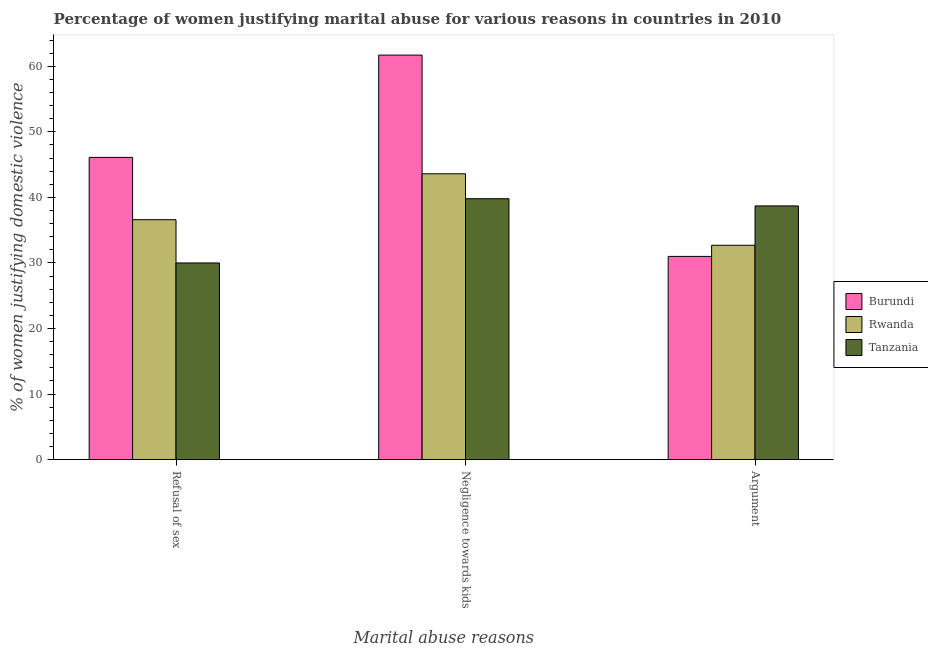How many groups of bars are there?
Make the answer very short. 3. How many bars are there on the 1st tick from the left?
Keep it short and to the point. 3. What is the label of the 1st group of bars from the left?
Keep it short and to the point. Refusal of sex. What is the percentage of women justifying domestic violence due to negligence towards kids in Tanzania?
Your response must be concise. 39.8. Across all countries, what is the maximum percentage of women justifying domestic violence due to arguments?
Make the answer very short. 38.7. Across all countries, what is the minimum percentage of women justifying domestic violence due to negligence towards kids?
Ensure brevity in your answer.  39.8. In which country was the percentage of women justifying domestic violence due to refusal of sex maximum?
Provide a succinct answer. Burundi. In which country was the percentage of women justifying domestic violence due to negligence towards kids minimum?
Make the answer very short. Tanzania. What is the total percentage of women justifying domestic violence due to negligence towards kids in the graph?
Give a very brief answer. 145.1. What is the difference between the percentage of women justifying domestic violence due to refusal of sex in Tanzania and the percentage of women justifying domestic violence due to negligence towards kids in Burundi?
Offer a terse response. -31.7. What is the average percentage of women justifying domestic violence due to negligence towards kids per country?
Make the answer very short. 48.37. What is the difference between the percentage of women justifying domestic violence due to arguments and percentage of women justifying domestic violence due to negligence towards kids in Rwanda?
Your answer should be compact. -10.9. What is the ratio of the percentage of women justifying domestic violence due to refusal of sex in Tanzania to that in Rwanda?
Offer a very short reply. 0.82. What is the difference between the highest and the lowest percentage of women justifying domestic violence due to negligence towards kids?
Your answer should be very brief. 21.9. In how many countries, is the percentage of women justifying domestic violence due to arguments greater than the average percentage of women justifying domestic violence due to arguments taken over all countries?
Offer a terse response. 1. What does the 1st bar from the left in Argument represents?
Ensure brevity in your answer.  Burundi. What does the 3rd bar from the right in Argument represents?
Make the answer very short. Burundi. Is it the case that in every country, the sum of the percentage of women justifying domestic violence due to refusal of sex and percentage of women justifying domestic violence due to negligence towards kids is greater than the percentage of women justifying domestic violence due to arguments?
Your response must be concise. Yes. How many countries are there in the graph?
Provide a short and direct response. 3. What is the difference between two consecutive major ticks on the Y-axis?
Make the answer very short. 10. Are the values on the major ticks of Y-axis written in scientific E-notation?
Offer a terse response. No. Does the graph contain any zero values?
Your answer should be compact. No. Does the graph contain grids?
Offer a terse response. No. How many legend labels are there?
Your answer should be very brief. 3. What is the title of the graph?
Ensure brevity in your answer.  Percentage of women justifying marital abuse for various reasons in countries in 2010. Does "Korea (Democratic)" appear as one of the legend labels in the graph?
Provide a short and direct response. No. What is the label or title of the X-axis?
Your answer should be very brief. Marital abuse reasons. What is the label or title of the Y-axis?
Your answer should be compact. % of women justifying domestic violence. What is the % of women justifying domestic violence of Burundi in Refusal of sex?
Your answer should be very brief. 46.1. What is the % of women justifying domestic violence of Rwanda in Refusal of sex?
Give a very brief answer. 36.6. What is the % of women justifying domestic violence of Burundi in Negligence towards kids?
Ensure brevity in your answer.  61.7. What is the % of women justifying domestic violence in Rwanda in Negligence towards kids?
Give a very brief answer. 43.6. What is the % of women justifying domestic violence of Tanzania in Negligence towards kids?
Ensure brevity in your answer.  39.8. What is the % of women justifying domestic violence in Burundi in Argument?
Ensure brevity in your answer.  31. What is the % of women justifying domestic violence in Rwanda in Argument?
Ensure brevity in your answer.  32.7. What is the % of women justifying domestic violence of Tanzania in Argument?
Offer a terse response. 38.7. Across all Marital abuse reasons, what is the maximum % of women justifying domestic violence in Burundi?
Offer a terse response. 61.7. Across all Marital abuse reasons, what is the maximum % of women justifying domestic violence of Rwanda?
Your response must be concise. 43.6. Across all Marital abuse reasons, what is the maximum % of women justifying domestic violence of Tanzania?
Offer a very short reply. 39.8. Across all Marital abuse reasons, what is the minimum % of women justifying domestic violence of Rwanda?
Offer a terse response. 32.7. Across all Marital abuse reasons, what is the minimum % of women justifying domestic violence in Tanzania?
Provide a short and direct response. 30. What is the total % of women justifying domestic violence in Burundi in the graph?
Your response must be concise. 138.8. What is the total % of women justifying domestic violence in Rwanda in the graph?
Provide a short and direct response. 112.9. What is the total % of women justifying domestic violence in Tanzania in the graph?
Your response must be concise. 108.5. What is the difference between the % of women justifying domestic violence of Burundi in Refusal of sex and that in Negligence towards kids?
Provide a succinct answer. -15.6. What is the difference between the % of women justifying domestic violence of Rwanda in Refusal of sex and that in Negligence towards kids?
Provide a short and direct response. -7. What is the difference between the % of women justifying domestic violence in Tanzania in Refusal of sex and that in Negligence towards kids?
Keep it short and to the point. -9.8. What is the difference between the % of women justifying domestic violence of Rwanda in Refusal of sex and that in Argument?
Ensure brevity in your answer.  3.9. What is the difference between the % of women justifying domestic violence of Tanzania in Refusal of sex and that in Argument?
Give a very brief answer. -8.7. What is the difference between the % of women justifying domestic violence of Burundi in Negligence towards kids and that in Argument?
Offer a very short reply. 30.7. What is the difference between the % of women justifying domestic violence in Burundi in Refusal of sex and the % of women justifying domestic violence in Rwanda in Negligence towards kids?
Offer a terse response. 2.5. What is the difference between the % of women justifying domestic violence of Rwanda in Refusal of sex and the % of women justifying domestic violence of Tanzania in Negligence towards kids?
Your answer should be compact. -3.2. What is the difference between the % of women justifying domestic violence in Burundi in Refusal of sex and the % of women justifying domestic violence in Tanzania in Argument?
Provide a succinct answer. 7.4. What is the difference between the % of women justifying domestic violence in Burundi in Negligence towards kids and the % of women justifying domestic violence in Rwanda in Argument?
Ensure brevity in your answer.  29. What is the average % of women justifying domestic violence of Burundi per Marital abuse reasons?
Ensure brevity in your answer.  46.27. What is the average % of women justifying domestic violence of Rwanda per Marital abuse reasons?
Provide a succinct answer. 37.63. What is the average % of women justifying domestic violence of Tanzania per Marital abuse reasons?
Provide a succinct answer. 36.17. What is the difference between the % of women justifying domestic violence in Burundi and % of women justifying domestic violence in Rwanda in Negligence towards kids?
Provide a short and direct response. 18.1. What is the difference between the % of women justifying domestic violence of Burundi and % of women justifying domestic violence of Tanzania in Negligence towards kids?
Ensure brevity in your answer.  21.9. What is the difference between the % of women justifying domestic violence of Rwanda and % of women justifying domestic violence of Tanzania in Negligence towards kids?
Provide a short and direct response. 3.8. What is the difference between the % of women justifying domestic violence of Burundi and % of women justifying domestic violence of Rwanda in Argument?
Give a very brief answer. -1.7. What is the difference between the % of women justifying domestic violence of Burundi and % of women justifying domestic violence of Tanzania in Argument?
Keep it short and to the point. -7.7. What is the difference between the % of women justifying domestic violence in Rwanda and % of women justifying domestic violence in Tanzania in Argument?
Offer a very short reply. -6. What is the ratio of the % of women justifying domestic violence in Burundi in Refusal of sex to that in Negligence towards kids?
Offer a very short reply. 0.75. What is the ratio of the % of women justifying domestic violence of Rwanda in Refusal of sex to that in Negligence towards kids?
Your response must be concise. 0.84. What is the ratio of the % of women justifying domestic violence of Tanzania in Refusal of sex to that in Negligence towards kids?
Provide a succinct answer. 0.75. What is the ratio of the % of women justifying domestic violence of Burundi in Refusal of sex to that in Argument?
Keep it short and to the point. 1.49. What is the ratio of the % of women justifying domestic violence of Rwanda in Refusal of sex to that in Argument?
Your response must be concise. 1.12. What is the ratio of the % of women justifying domestic violence of Tanzania in Refusal of sex to that in Argument?
Offer a very short reply. 0.78. What is the ratio of the % of women justifying domestic violence in Burundi in Negligence towards kids to that in Argument?
Keep it short and to the point. 1.99. What is the ratio of the % of women justifying domestic violence in Tanzania in Negligence towards kids to that in Argument?
Offer a very short reply. 1.03. What is the difference between the highest and the second highest % of women justifying domestic violence in Rwanda?
Your answer should be very brief. 7. What is the difference between the highest and the lowest % of women justifying domestic violence in Burundi?
Make the answer very short. 30.7. What is the difference between the highest and the lowest % of women justifying domestic violence of Tanzania?
Keep it short and to the point. 9.8. 